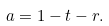<formula> <loc_0><loc_0><loc_500><loc_500>a = 1 - t - r .</formula> 